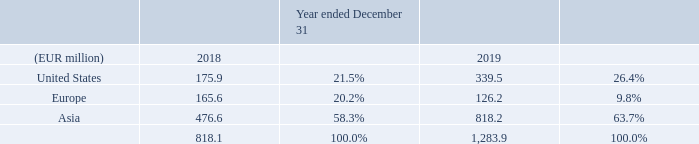REVENUE
The sales cycle from quotation to shipment for our Front-end equipment generally takes several months, depending on capacity utilization and the urgency of the order. Usually, acceptance is within four months after shipment. The sales cycle is longer for equipment that is installed at the customer’s site for evaluation prior to sale. The typical trial period ranges from six months to two years after installation.
Our revenues are concentrated in Asia, the United States and Europe. The following table shows the geographic distribution of our revenue for 2018 and 2019:
Where are the revenues of this company concentrated? Asia, the united states and europe. What is the usual acceptance duration after shipment? Within four months. What is the base currency used for the table? Eur. What is the average revenue for United States in 2018 and 2019?
Answer scale should be: million. (175.9+339.5)/2
Answer: 257.7. How much more revenue does the company have in Asia have over Europe for 2019?
Answer scale should be: million. 818.2-126.2
Answer: 692. What is the average annual total revenue for all regions for 2018 and 2019?
Answer scale should be: million. (818.1+1,283.9)/2
Answer: 1051. 